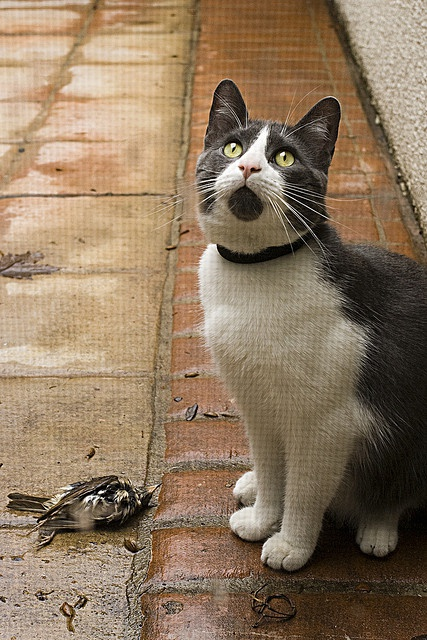Describe the objects in this image and their specific colors. I can see cat in tan, black, gray, and darkgray tones and bird in tan, black, and gray tones in this image. 